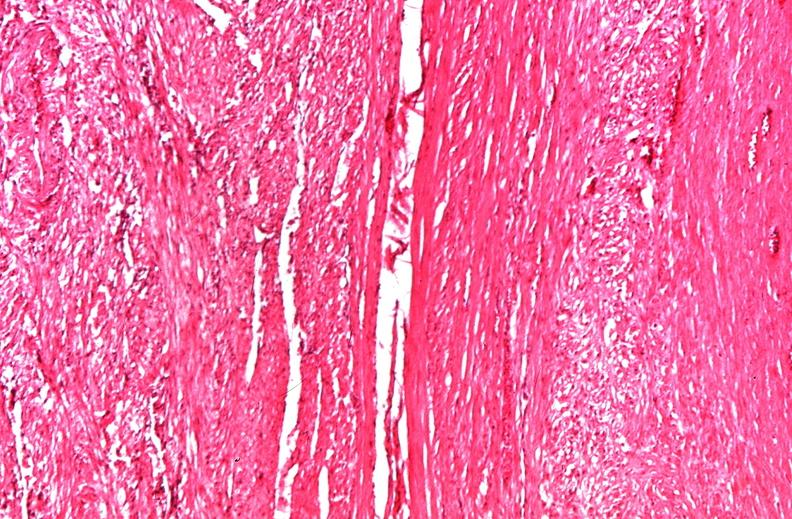what is present?
Answer the question using a single word or phrase. Female reproductive 